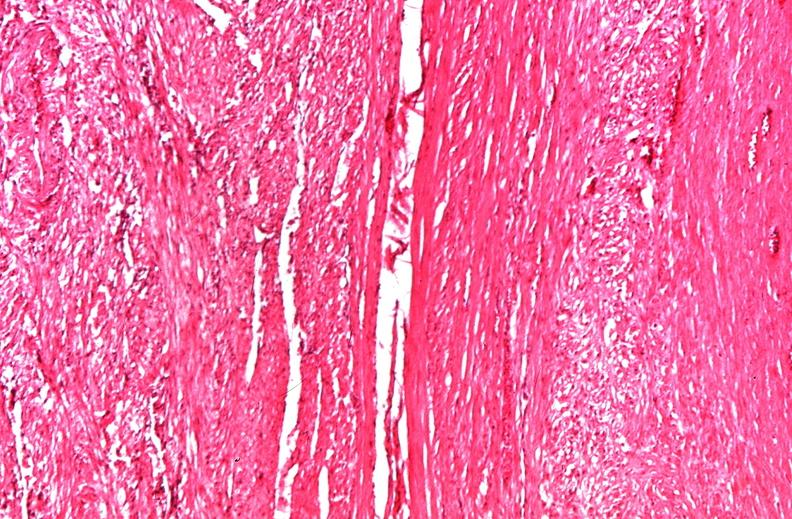what is present?
Answer the question using a single word or phrase. Female reproductive 